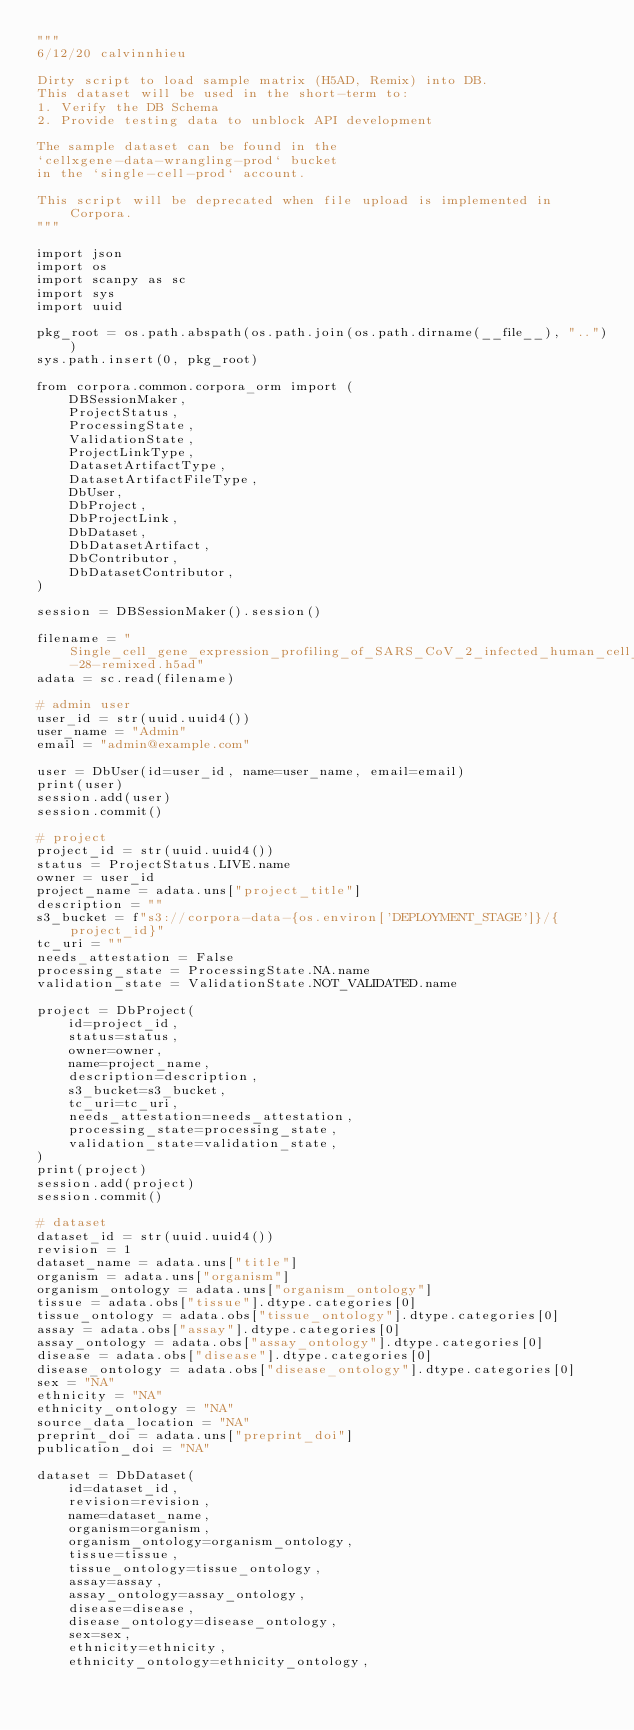Convert code to text. <code><loc_0><loc_0><loc_500><loc_500><_Python_>"""
6/12/20 calvinnhieu

Dirty script to load sample matrix (H5AD, Remix) into DB.
This dataset will be used in the short-term to:
1. Verify the DB Schema
2. Provide testing data to unblock API development

The sample dataset can be found in the
`cellxgene-data-wrangling-prod` bucket
in the `single-cell-prod` account.

This script will be deprecated when file upload is implemented in Corpora.
"""

import json
import os
import scanpy as sc
import sys
import uuid

pkg_root = os.path.abspath(os.path.join(os.path.dirname(__file__), ".."))
sys.path.insert(0, pkg_root)

from corpora.common.corpora_orm import (
    DBSessionMaker,
    ProjectStatus,
    ProcessingState,
    ValidationState,
    ProjectLinkType,
    DatasetArtifactType,
    DatasetArtifactFileType,
    DbUser,
    DbProject,
    DbProjectLink,
    DbDataset,
    DbDatasetArtifact,
    DbContributor,
    DbDatasetContributor,
)

session = DBSessionMaker().session()

filename = "Single_cell_gene_expression_profiling_of_SARS_CoV_2_infected_human_cell_lines_Calu_3-28-remixed.h5ad"
adata = sc.read(filename)

# admin user
user_id = str(uuid.uuid4())
user_name = "Admin"
email = "admin@example.com"

user = DbUser(id=user_id, name=user_name, email=email)
print(user)
session.add(user)
session.commit()

# project
project_id = str(uuid.uuid4())
status = ProjectStatus.LIVE.name
owner = user_id
project_name = adata.uns["project_title"]
description = ""
s3_bucket = f"s3://corpora-data-{os.environ['DEPLOYMENT_STAGE']}/{project_id}"
tc_uri = ""
needs_attestation = False
processing_state = ProcessingState.NA.name
validation_state = ValidationState.NOT_VALIDATED.name

project = DbProject(
    id=project_id,
    status=status,
    owner=owner,
    name=project_name,
    description=description,
    s3_bucket=s3_bucket,
    tc_uri=tc_uri,
    needs_attestation=needs_attestation,
    processing_state=processing_state,
    validation_state=validation_state,
)
print(project)
session.add(project)
session.commit()

# dataset
dataset_id = str(uuid.uuid4())
revision = 1
dataset_name = adata.uns["title"]
organism = adata.uns["organism"]
organism_ontology = adata.uns["organism_ontology"]
tissue = adata.obs["tissue"].dtype.categories[0]
tissue_ontology = adata.obs["tissue_ontology"].dtype.categories[0]
assay = adata.obs["assay"].dtype.categories[0]
assay_ontology = adata.obs["assay_ontology"].dtype.categories[0]
disease = adata.obs["disease"].dtype.categories[0]
disease_ontology = adata.obs["disease_ontology"].dtype.categories[0]
sex = "NA"
ethnicity = "NA"
ethnicity_ontology = "NA"
source_data_location = "NA"
preprint_doi = adata.uns["preprint_doi"]
publication_doi = "NA"

dataset = DbDataset(
    id=dataset_id,
    revision=revision,
    name=dataset_name,
    organism=organism,
    organism_ontology=organism_ontology,
    tissue=tissue,
    tissue_ontology=tissue_ontology,
    assay=assay,
    assay_ontology=assay_ontology,
    disease=disease,
    disease_ontology=disease_ontology,
    sex=sex,
    ethnicity=ethnicity,
    ethnicity_ontology=ethnicity_ontology,</code> 